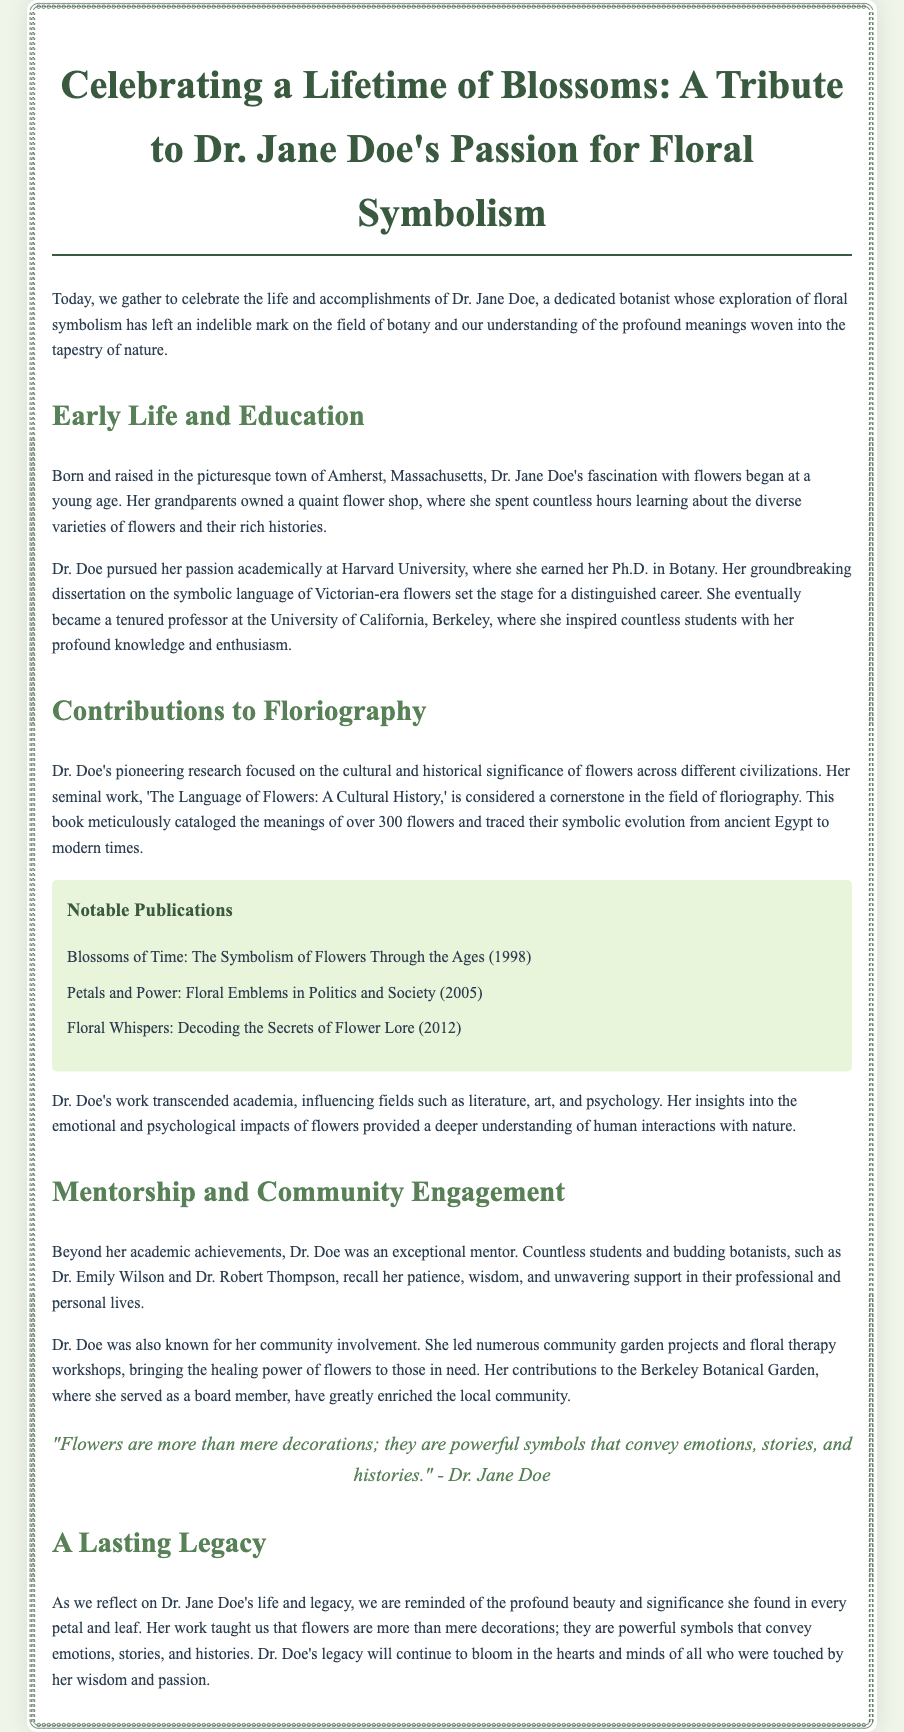What was Dr. Jane Doe's Ph.D. specialization? Dr. Jane Doe earned her Ph.D. in Botany.
Answer: Botany Where did Dr. Doe serve as a tenured professor? Dr. Doe became a tenured professor at the University of California, Berkeley.
Answer: University of California, Berkeley What is the title of Dr. Doe's seminal work? Her seminal work is titled 'The Language of Flowers: A Cultural History.'
Answer: The Language of Flowers: A Cultural History Which community project did Dr. Doe lead? She led numerous community garden projects.
Answer: Community garden projects What phrase encapsulates Dr. Doe's view of flowers? Dr. Jane Doe stated, "Flowers are more than mere decorations."
Answer: More than mere decorations How many notable publications are listed in the document? The document lists three notable publications.
Answer: Three Who are two students mentored by Dr. Doe? Two students she mentored are Dr. Emily Wilson and Dr. Robert Thompson.
Answer: Dr. Emily Wilson and Dr. Robert Thompson In which town was Dr. Jane Doe born? Dr. Jane Doe was born in Amherst, Massachusetts.
Answer: Amherst, Massachusetts What year was 'Blossoms of Time' published? 'Blossoms of Time' was published in 1998.
Answer: 1998 